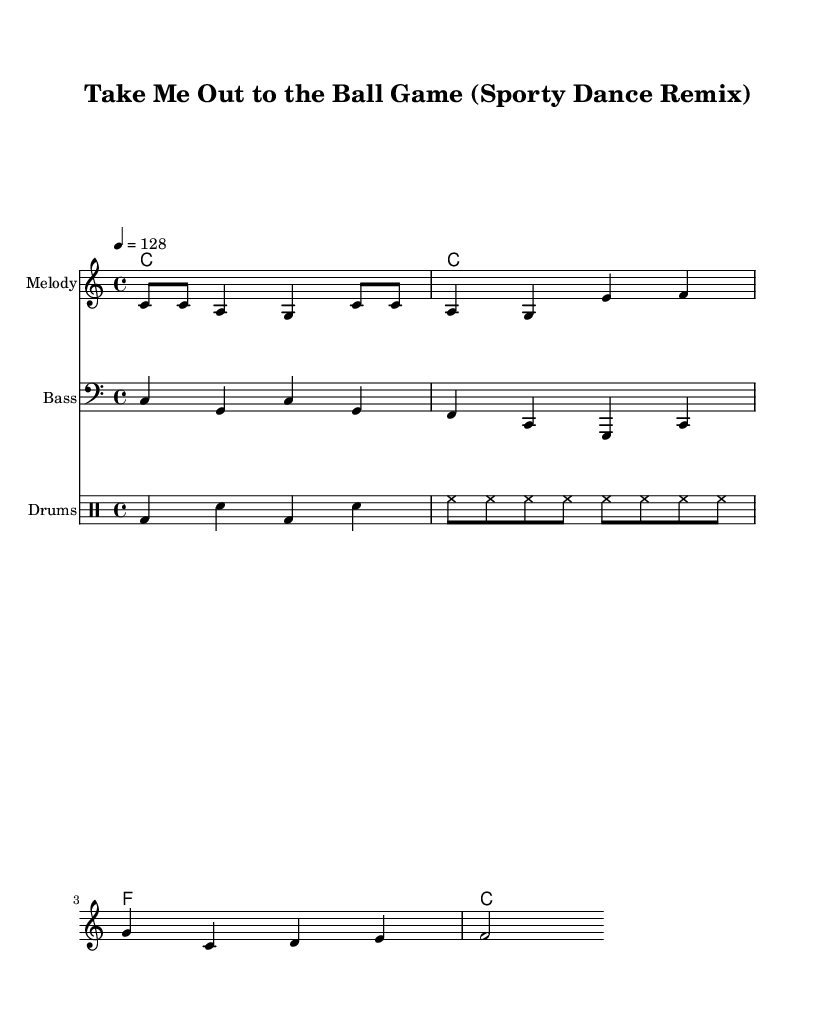What is the key signature of this music? The key signature is C major, which has no sharps or flats.
Answer: C major What is the time signature of this piece? The time signature is indicated as 4/4, meaning there are four beats in a measure.
Answer: 4/4 What is the tempo marking for this composition? The tempo is marked as 4 = 128, indicating the speed at which the piece should be played.
Answer: 128 How many measures are in the melody section? The melody consists of two complete measures, each containing four beats, totaling eight beats.
Answer: 2 What type of rhythm is predominantly used in the drums? The drum rhythm features a combination of bass and snare hits that create a danceable beat typical in dance music.
Answer: Danceable Which instrument plays the melody? The melody is performed by a staff assigned specifically to the melody part, identified in the score.
Answer: Melody What is the last note in the melody? The last note in the melody is a sustained note that concludes the phrase, providing resolution.
Answer: G 